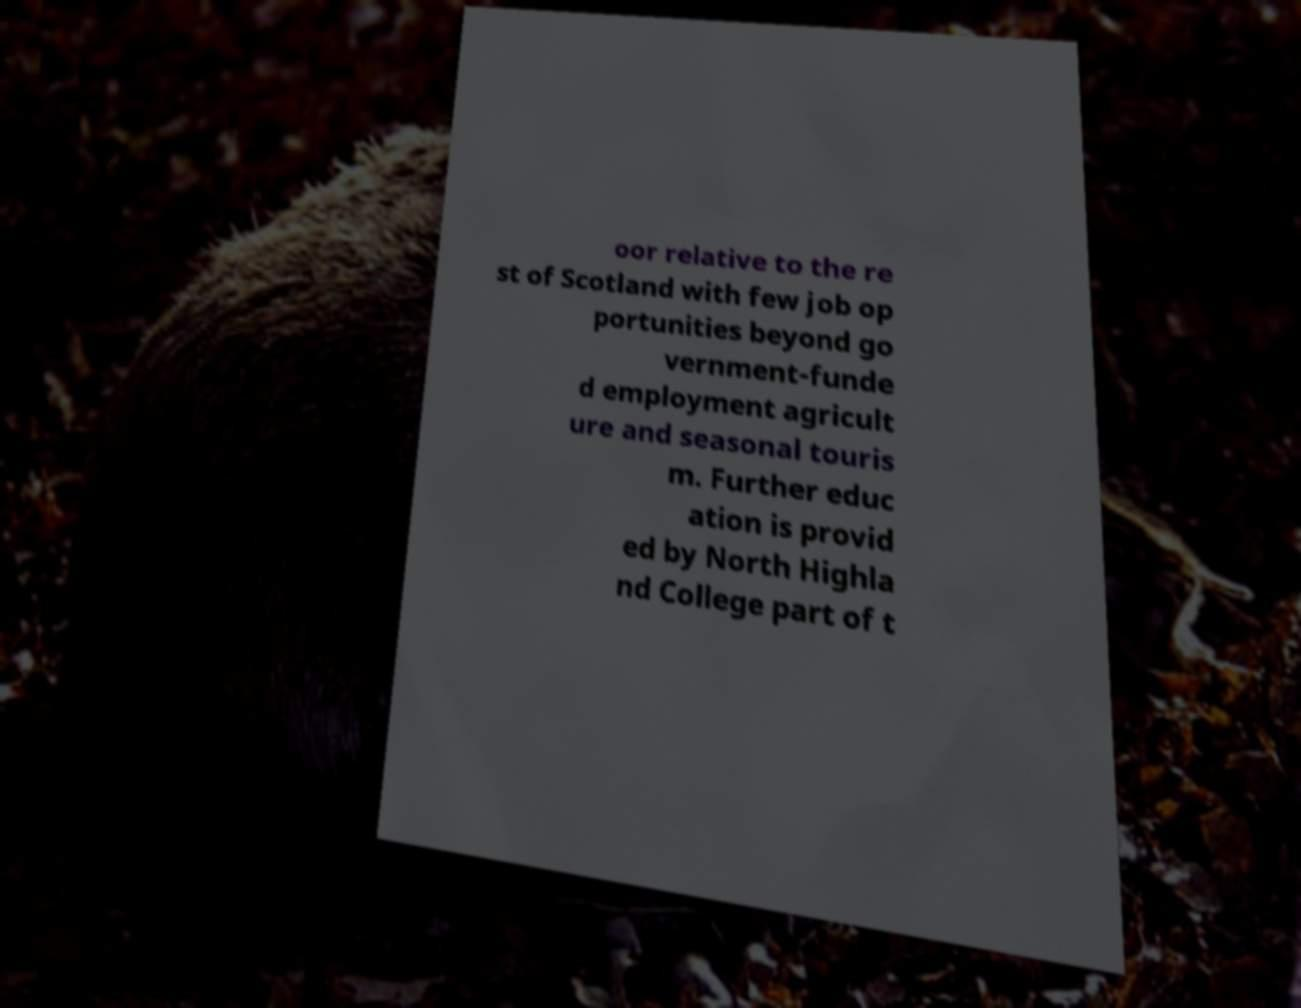Can you accurately transcribe the text from the provided image for me? oor relative to the re st of Scotland with few job op portunities beyond go vernment-funde d employment agricult ure and seasonal touris m. Further educ ation is provid ed by North Highla nd College part of t 